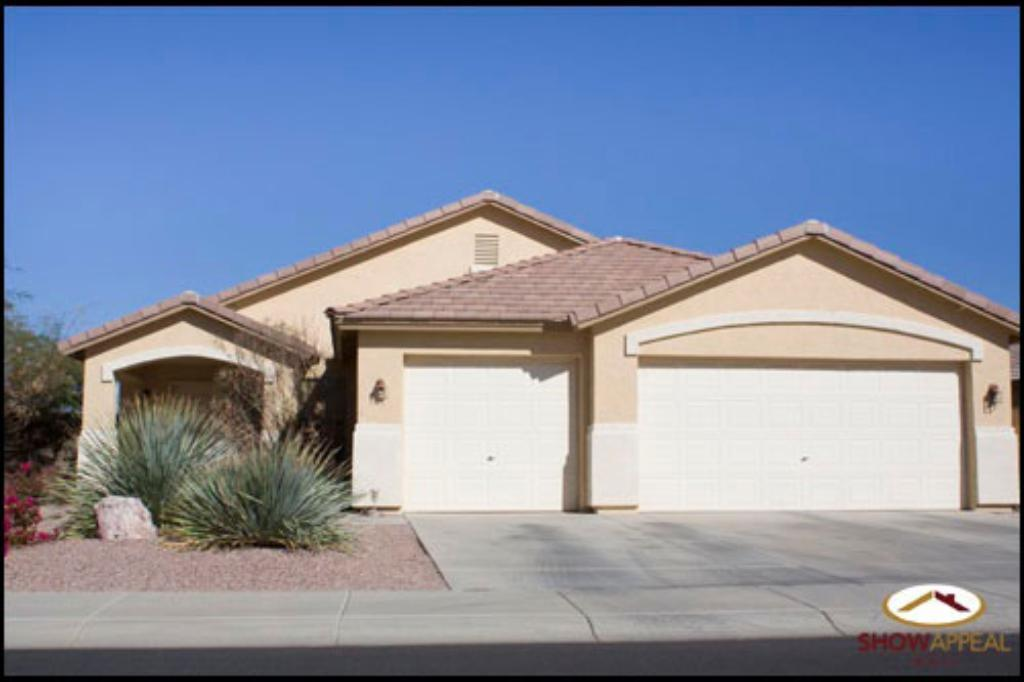What type of structure is visible in the image? There is a building in the image. What can be seen on the left side of the image? There are trees on the left side of the image. What types of vegetation are present in the image? There are plants, flowers, and grass in the image. What is visible at the top of the image? The sky is visible at the top of the image. Can you describe the watermark in the image? There is a watermark in the bottom right corner of the image. What type of celery is being served on the ship in the image? There is no celery or ship present in the image. Can you tell me the name of the judge who is presiding over the case in the image? There is no judge or case present in the image. 